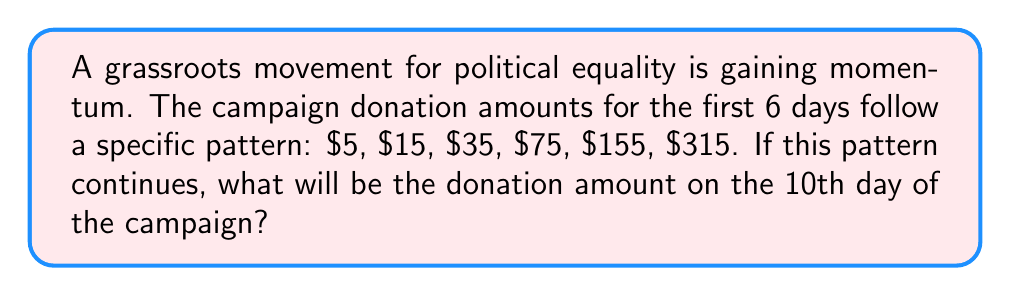Help me with this question. Let's analyze the pattern step-by-step:

1) First, calculate the differences between consecutive terms:
   $15 - 5 = 10$
   $35 - 15 = 20$
   $75 - 35 = 40$
   $155 - 75 = 80$
   $315 - 155 = 160$

2) We can see that these differences are doubling each time:
   $10 \rightarrow 20 \rightarrow 40 \rightarrow 80 \rightarrow 160$

3) This suggests that the nth term of the sequence can be expressed as:
   $a_n = a_{n-1} + 5 \cdot 2^{n-2}$ for $n \geq 2$, where $a_1 = 5$

4) Let's verify this formula for the given terms:
   $a_2 = 5 + 5 \cdot 2^0 = 5 + 5 = 15$
   $a_3 = 15 + 5 \cdot 2^1 = 15 + 10 = 35$
   $a_4 = 35 + 5 \cdot 2^2 = 35 + 20 = 75$
   $a_5 = 75 + 5 \cdot 2^3 = 75 + 40 = 115$
   $a_6 = 155 + 5 \cdot 2^4 = 155 + 80 = 315$

5) Now, let's calculate the 7th, 8th, 9th, and 10th terms:
   $a_7 = 315 + 5 \cdot 2^5 = 315 + 160 = 475$
   $a_8 = 475 + 5 \cdot 2^6 = 475 + 320 = 795$
   $a_9 = 795 + 5 \cdot 2^7 = 795 + 640 = 1435$
   $a_{10} = 1435 + 5 \cdot 2^8 = 1435 + 1280 = 2715$

Therefore, the donation amount on the 10th day will be $2715.
Answer: $2715 